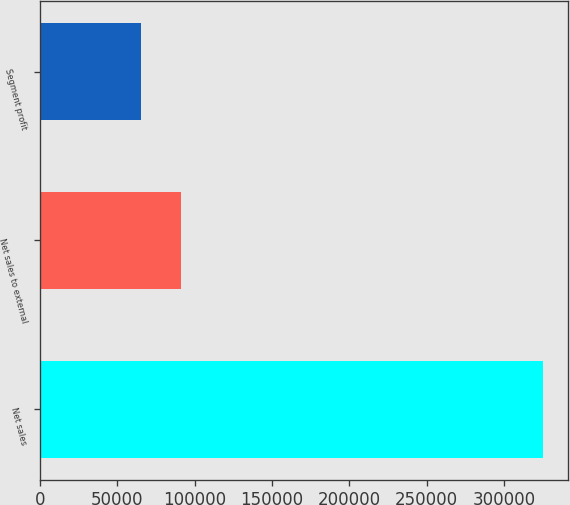Convert chart. <chart><loc_0><loc_0><loc_500><loc_500><bar_chart><fcel>Net sales<fcel>Net sales to external<fcel>Segment profit<nl><fcel>324901<fcel>91414<fcel>65471<nl></chart> 